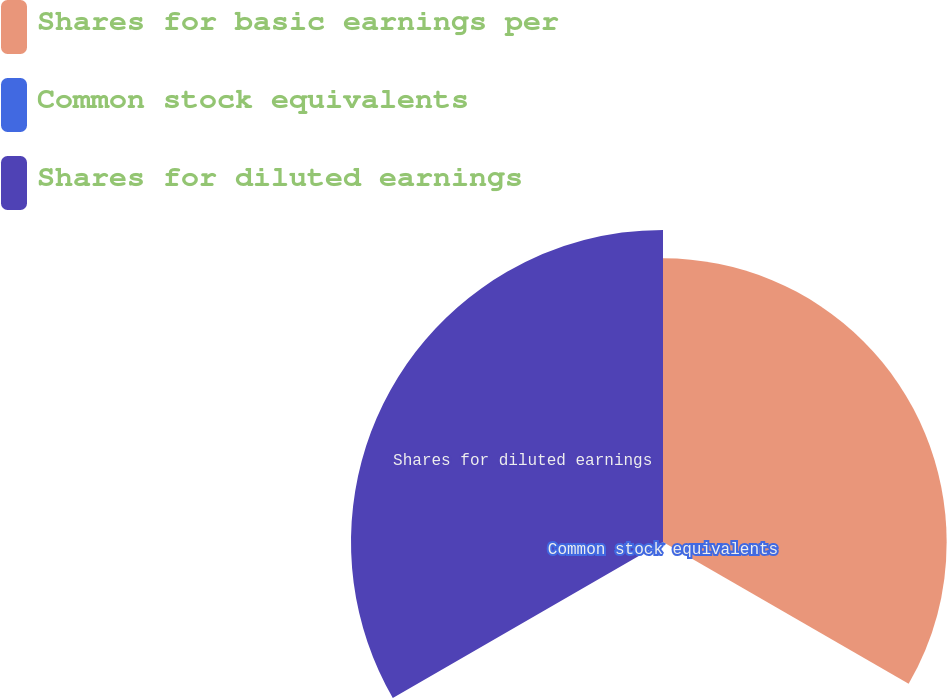<chart> <loc_0><loc_0><loc_500><loc_500><pie_chart><fcel>Shares for basic earnings per<fcel>Common stock equivalents<fcel>Shares for diluted earnings<nl><fcel>47.34%<fcel>0.59%<fcel>52.07%<nl></chart> 